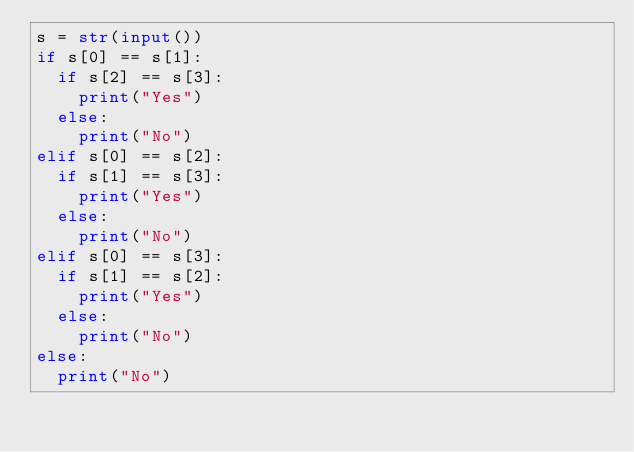<code> <loc_0><loc_0><loc_500><loc_500><_Python_>s = str(input())
if s[0] == s[1]:
  if s[2] == s[3]:
    print("Yes")
  else:
    print("No")
elif s[0] == s[2]:
  if s[1] == s[3]:
    print("Yes")
  else:
    print("No")
elif s[0] == s[3]:
  if s[1] == s[2]:
    print("Yes")
  else:
    print("No")
else:
  print("No")</code> 